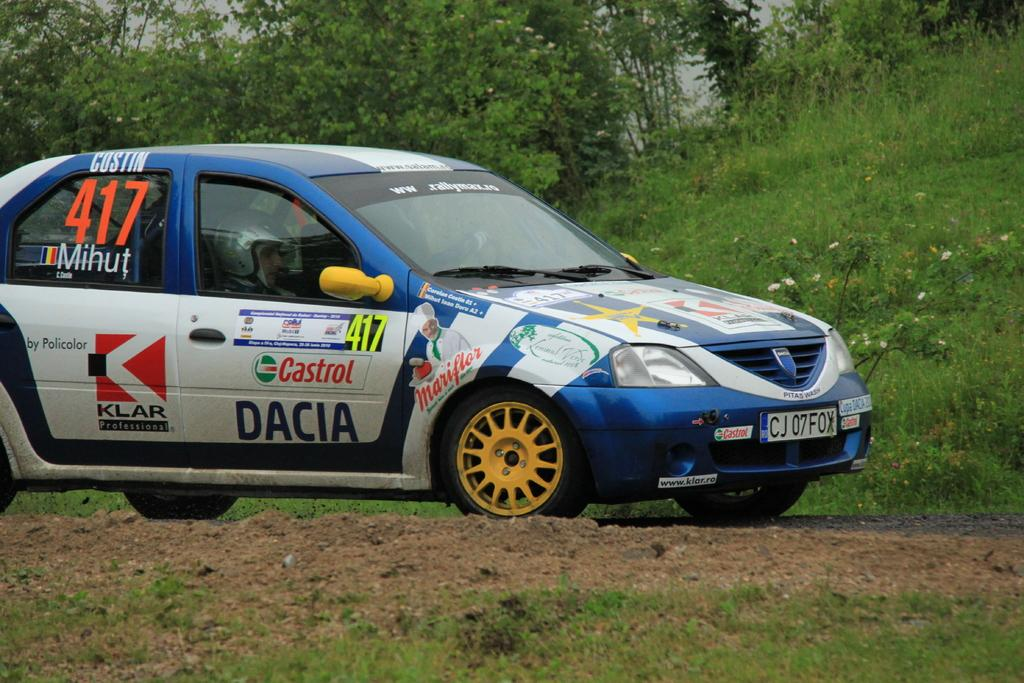What is on the ground in the image? There is a car on the ground in the image. What type of vegetation can be seen in the image? Grass, plants, and trees are visible in the image. What is visible in the background of the image? The sky is visible in the image. Can you determine the time of day the image was taken? The image was likely taken during the day, as the sky is visible. What type of goat can be seen standing on the crate in the image? There is no goat or crate present in the image. What song is being played in the background of the image? There is no audio or music present in the image, so it is not possible to determine what song might be playing. 